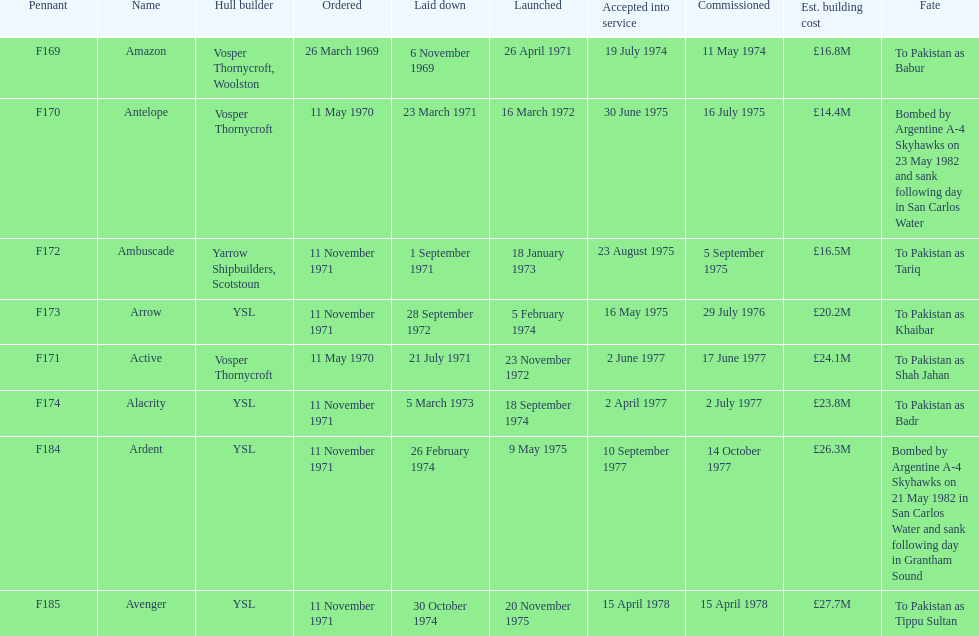What was the former ship? Ambuscade. 